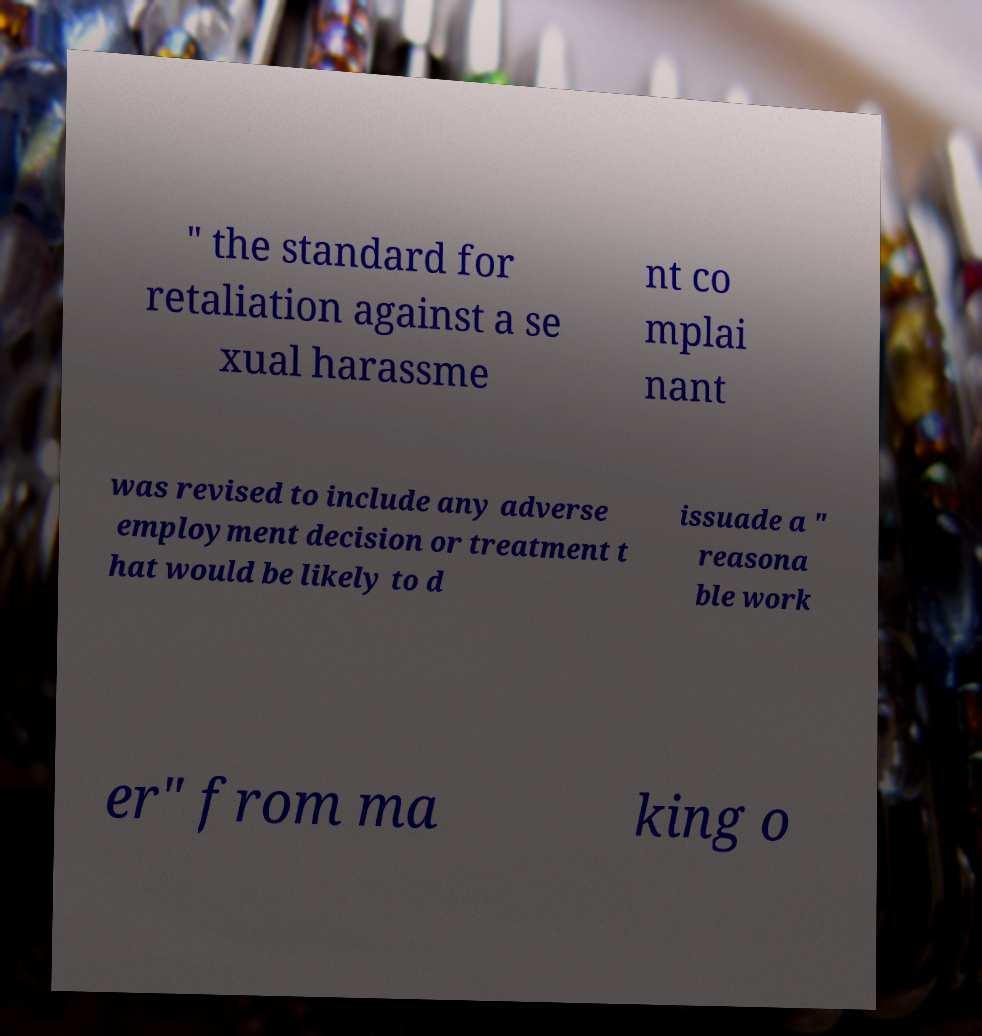There's text embedded in this image that I need extracted. Can you transcribe it verbatim? " the standard for retaliation against a se xual harassme nt co mplai nant was revised to include any adverse employment decision or treatment t hat would be likely to d issuade a " reasona ble work er" from ma king o 